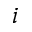<formula> <loc_0><loc_0><loc_500><loc_500>i</formula> 